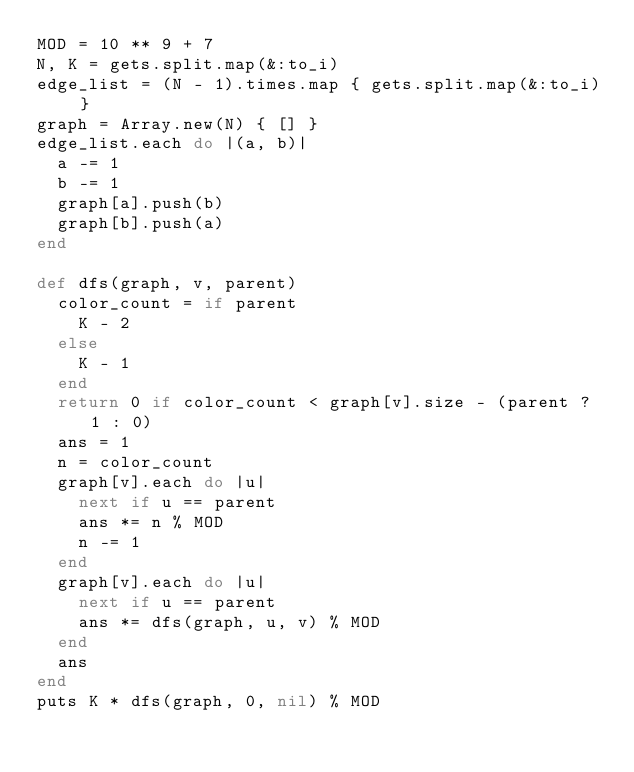<code> <loc_0><loc_0><loc_500><loc_500><_Ruby_>MOD = 10 ** 9 + 7
N, K = gets.split.map(&:to_i)
edge_list = (N - 1).times.map { gets.split.map(&:to_i) }
graph = Array.new(N) { [] }
edge_list.each do |(a, b)|
  a -= 1
  b -= 1
  graph[a].push(b)
  graph[b].push(a)
end

def dfs(graph, v, parent)
  color_count = if parent
    K - 2
  else
    K - 1
  end
  return 0 if color_count < graph[v].size - (parent ? 1 : 0)
  ans = 1
  n = color_count
  graph[v].each do |u|
    next if u == parent
    ans *= n % MOD
    n -= 1
  end
  graph[v].each do |u|
    next if u == parent
    ans *= dfs(graph, u, v) % MOD
  end
  ans
end
puts K * dfs(graph, 0, nil) % MOD
</code> 